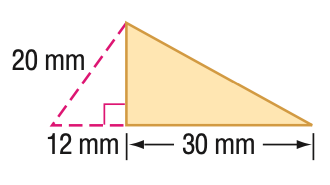Answer the mathemtical geometry problem and directly provide the correct option letter.
Question: Find the perimeter of the triangle. Round to the nearest tenth if necessary.
Choices: A: 62 B: 76 C: 80 D: 91.3 C 